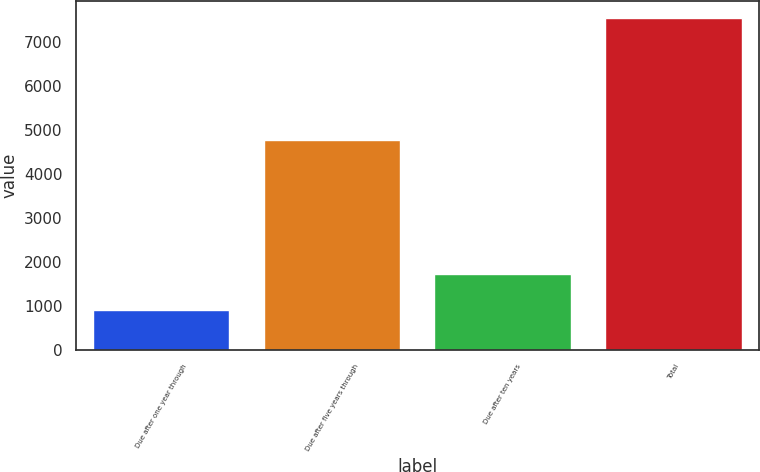<chart> <loc_0><loc_0><loc_500><loc_500><bar_chart><fcel>Due after one year through<fcel>Due after five years through<fcel>Due after ten years<fcel>Total<nl><fcel>909<fcel>4775<fcel>1739<fcel>7548<nl></chart> 